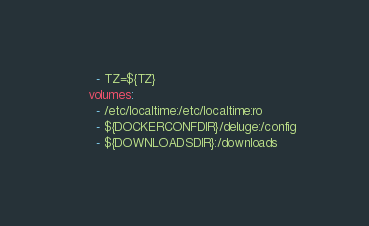<code> <loc_0><loc_0><loc_500><loc_500><_YAML_>      - TZ=${TZ}
    volumes:
      - /etc/localtime:/etc/localtime:ro
      - ${DOCKERCONFDIR}/deluge:/config
      - ${DOWNLOADSDIR}:/downloads
</code> 